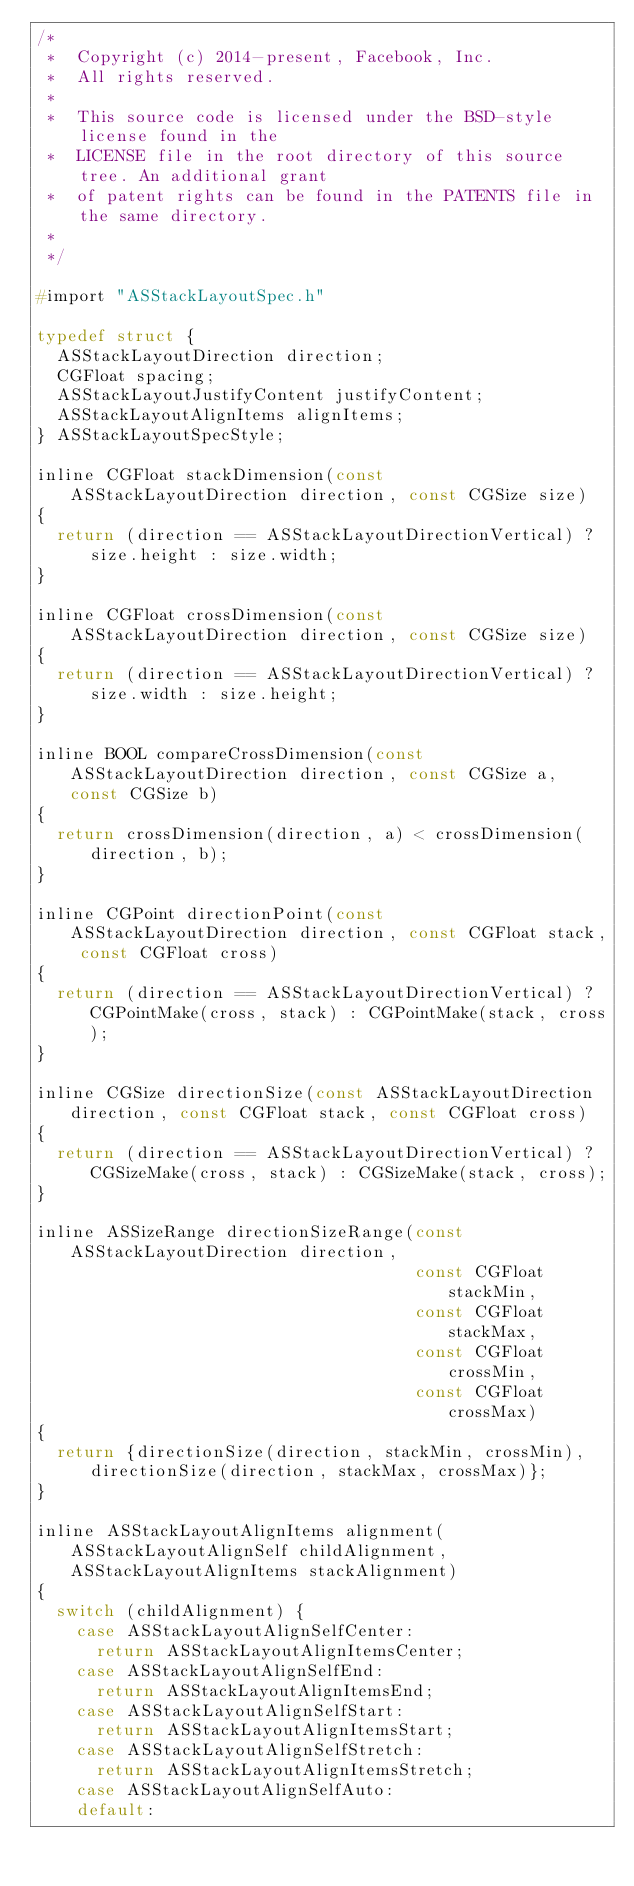Convert code to text. <code><loc_0><loc_0><loc_500><loc_500><_C_>/*
 *  Copyright (c) 2014-present, Facebook, Inc.
 *  All rights reserved.
 *
 *  This source code is licensed under the BSD-style license found in the
 *  LICENSE file in the root directory of this source tree. An additional grant
 *  of patent rights can be found in the PATENTS file in the same directory.
 *
 */

#import "ASStackLayoutSpec.h"

typedef struct {
  ASStackLayoutDirection direction;
  CGFloat spacing;
  ASStackLayoutJustifyContent justifyContent;
  ASStackLayoutAlignItems alignItems;
} ASStackLayoutSpecStyle;

inline CGFloat stackDimension(const ASStackLayoutDirection direction, const CGSize size)
{
  return (direction == ASStackLayoutDirectionVertical) ? size.height : size.width;
}

inline CGFloat crossDimension(const ASStackLayoutDirection direction, const CGSize size)
{
  return (direction == ASStackLayoutDirectionVertical) ? size.width : size.height;
}

inline BOOL compareCrossDimension(const ASStackLayoutDirection direction, const CGSize a, const CGSize b)
{
  return crossDimension(direction, a) < crossDimension(direction, b);
}

inline CGPoint directionPoint(const ASStackLayoutDirection direction, const CGFloat stack, const CGFloat cross)
{
  return (direction == ASStackLayoutDirectionVertical) ? CGPointMake(cross, stack) : CGPointMake(stack, cross);
}

inline CGSize directionSize(const ASStackLayoutDirection direction, const CGFloat stack, const CGFloat cross)
{
  return (direction == ASStackLayoutDirectionVertical) ? CGSizeMake(cross, stack) : CGSizeMake(stack, cross);
}

inline ASSizeRange directionSizeRange(const ASStackLayoutDirection direction,
                                      const CGFloat stackMin,
                                      const CGFloat stackMax,
                                      const CGFloat crossMin,
                                      const CGFloat crossMax)
{
  return {directionSize(direction, stackMin, crossMin), directionSize(direction, stackMax, crossMax)};
}

inline ASStackLayoutAlignItems alignment(ASStackLayoutAlignSelf childAlignment, ASStackLayoutAlignItems stackAlignment)
{
  switch (childAlignment) {
    case ASStackLayoutAlignSelfCenter:
      return ASStackLayoutAlignItemsCenter;
    case ASStackLayoutAlignSelfEnd:
      return ASStackLayoutAlignItemsEnd;
    case ASStackLayoutAlignSelfStart:
      return ASStackLayoutAlignItemsStart;
    case ASStackLayoutAlignSelfStretch:
      return ASStackLayoutAlignItemsStretch;
    case ASStackLayoutAlignSelfAuto:
    default:</code> 